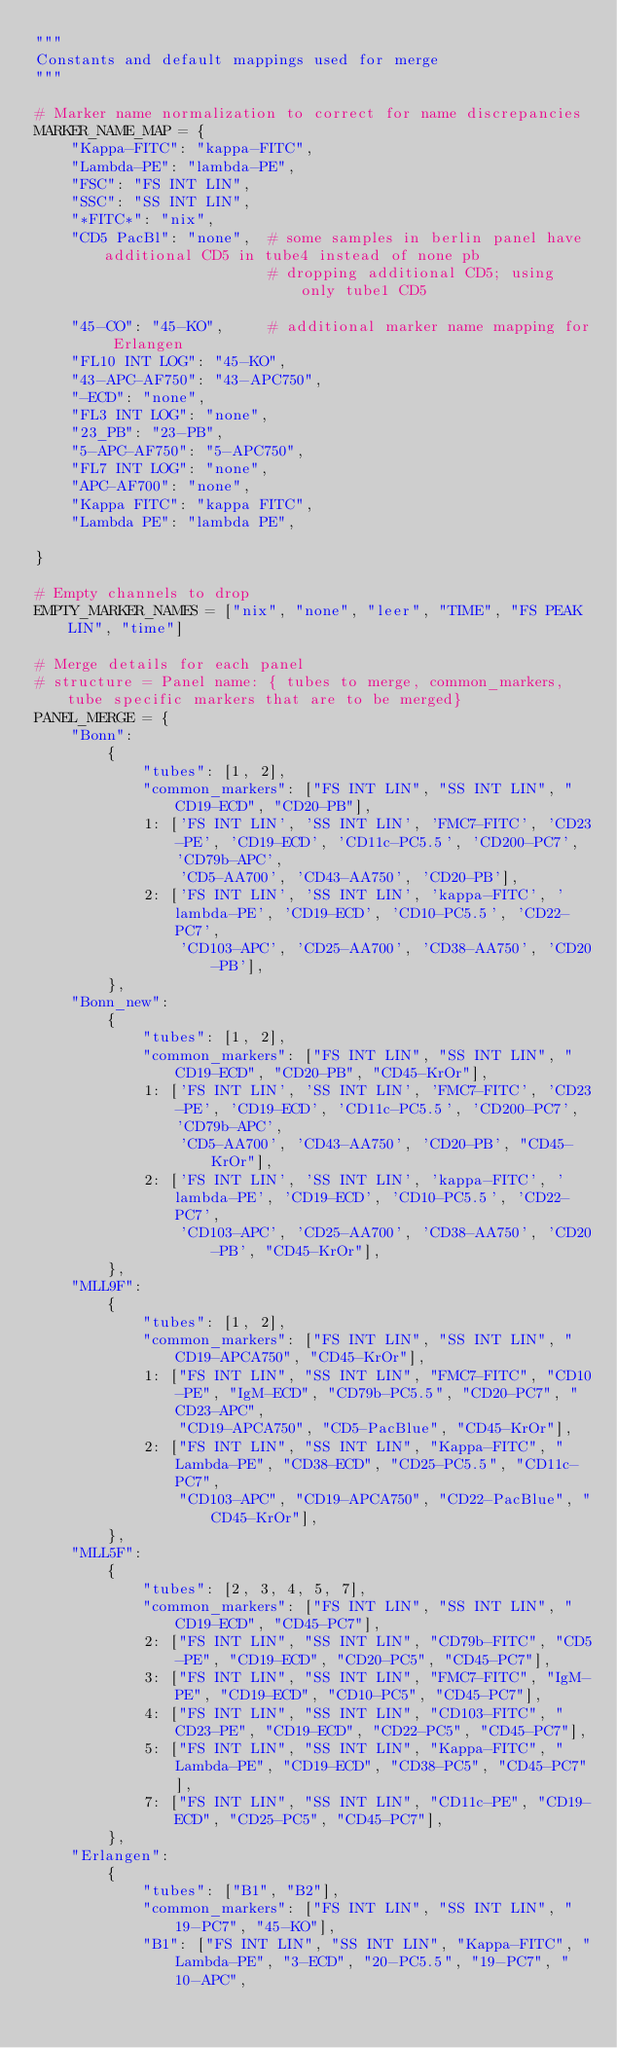<code> <loc_0><loc_0><loc_500><loc_500><_Python_>"""
Constants and default mappings used for merge
"""

# Marker name normalization to correct for name discrepancies
MARKER_NAME_MAP = {
    "Kappa-FITC": "kappa-FITC",
    "Lambda-PE": "lambda-PE",
    "FSC": "FS INT LIN",
    "SSC": "SS INT LIN",
    "*FITC*": "nix",
    "CD5 PacBl": "none",  # some samples in berlin panel have additional CD5 in tube4 instead of none pb
                          # dropping additional CD5; using only tube1 CD5

    "45-CO": "45-KO",     # additional marker name mapping for Erlangen
    "FL10 INT LOG": "45-KO",
    "43-APC-AF750": "43-APC750",
    "-ECD": "none",
    "FL3 INT LOG": "none",
    "23_PB": "23-PB",
    "5-APC-AF750": "5-APC750",
    "FL7 INT LOG": "none",
    "APC-AF700": "none",
    "Kappa FITC": "kappa FITC",
    "Lambda PE": "lambda PE",

}

# Empty channels to drop
EMPTY_MARKER_NAMES = ["nix", "none", "leer", "TIME", "FS PEAK LIN", "time"]

# Merge details for each panel
# structure = Panel name: { tubes to merge, common_markers, tube specific markers that are to be merged}
PANEL_MERGE = {
    "Bonn":
        {
            "tubes": [1, 2],
            "common_markers": ["FS INT LIN", "SS INT LIN", "CD19-ECD", "CD20-PB"],
            1: ['FS INT LIN', 'SS INT LIN', 'FMC7-FITC', 'CD23-PE', 'CD19-ECD', 'CD11c-PC5.5', 'CD200-PC7', 'CD79b-APC',
                'CD5-AA700', 'CD43-AA750', 'CD20-PB'],
            2: ['FS INT LIN', 'SS INT LIN', 'kappa-FITC', 'lambda-PE', 'CD19-ECD', 'CD10-PC5.5', 'CD22-PC7',
                'CD103-APC', 'CD25-AA700', 'CD38-AA750', 'CD20-PB'],
        },
    "Bonn_new":
        {
            "tubes": [1, 2],
            "common_markers": ["FS INT LIN", "SS INT LIN", "CD19-ECD", "CD20-PB", "CD45-KrOr"],
            1: ['FS INT LIN', 'SS INT LIN', 'FMC7-FITC', 'CD23-PE', 'CD19-ECD', 'CD11c-PC5.5', 'CD200-PC7', 'CD79b-APC',
                'CD5-AA700', 'CD43-AA750', 'CD20-PB', "CD45-KrOr"],
            2: ['FS INT LIN', 'SS INT LIN', 'kappa-FITC', 'lambda-PE', 'CD19-ECD', 'CD10-PC5.5', 'CD22-PC7',
                'CD103-APC', 'CD25-AA700', 'CD38-AA750', 'CD20-PB', "CD45-KrOr"],
        },
    "MLL9F":
        {
            "tubes": [1, 2],
            "common_markers": ["FS INT LIN", "SS INT LIN", "CD19-APCA750", "CD45-KrOr"],
            1: ["FS INT LIN", "SS INT LIN", "FMC7-FITC", "CD10-PE", "IgM-ECD", "CD79b-PC5.5", "CD20-PC7", "CD23-APC",
                "CD19-APCA750", "CD5-PacBlue", "CD45-KrOr"],
            2: ["FS INT LIN", "SS INT LIN", "Kappa-FITC", "Lambda-PE", "CD38-ECD", "CD25-PC5.5", "CD11c-PC7",
                "CD103-APC", "CD19-APCA750", "CD22-PacBlue", "CD45-KrOr"],
        },
    "MLL5F":
        {
            "tubes": [2, 3, 4, 5, 7],
            "common_markers": ["FS INT LIN", "SS INT LIN", "CD19-ECD", "CD45-PC7"],
            2: ["FS INT LIN", "SS INT LIN", "CD79b-FITC", "CD5-PE", "CD19-ECD", "CD20-PC5", "CD45-PC7"],
            3: ["FS INT LIN", "SS INT LIN", "FMC7-FITC", "IgM-PE", "CD19-ECD", "CD10-PC5", "CD45-PC7"],
            4: ["FS INT LIN", "SS INT LIN", "CD103-FITC", "CD23-PE", "CD19-ECD", "CD22-PC5", "CD45-PC7"],
            5: ["FS INT LIN", "SS INT LIN", "Kappa-FITC", "Lambda-PE", "CD19-ECD", "CD38-PC5", "CD45-PC7"],
            7: ["FS INT LIN", "SS INT LIN", "CD11c-PE", "CD19-ECD", "CD25-PC5", "CD45-PC7"],
        },
    "Erlangen":
        {
            "tubes": ["B1", "B2"],
            "common_markers": ["FS INT LIN", "SS INT LIN", "19-PC7", "45-KO"],
            "B1": ["FS INT LIN", "SS INT LIN", "Kappa-FITC", "Lambda-PE", "3-ECD", "20-PC5.5", "19-PC7", "10-APC",</code> 